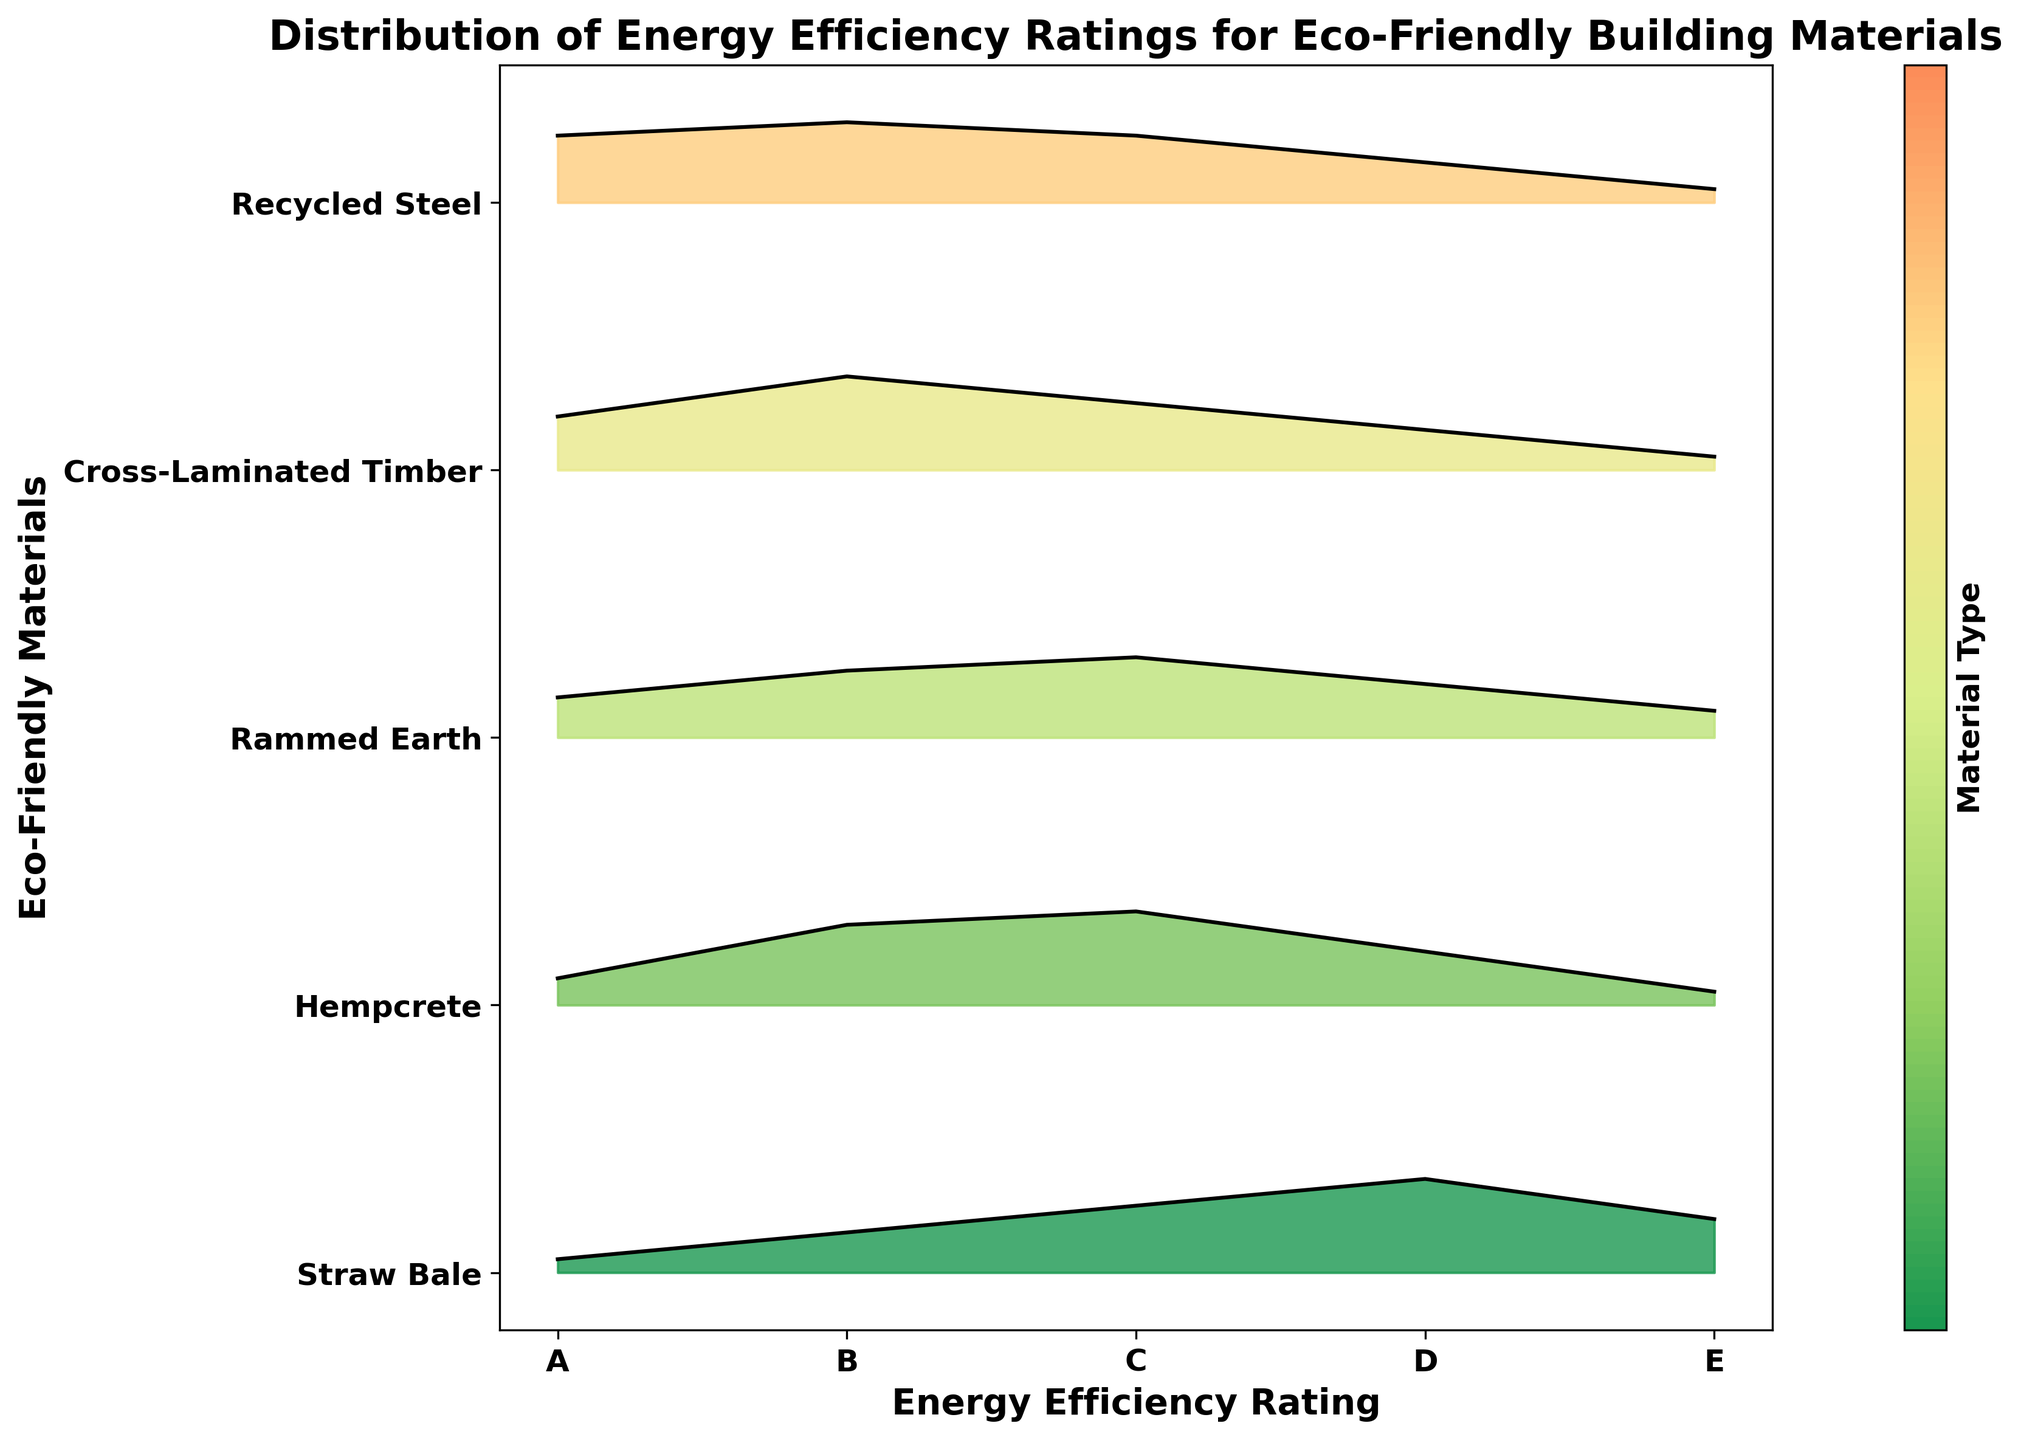What is the title of the plot? The title is typically located at the top of the plot. It summarizes what the plot represents.
Answer: Distribution of Energy Efficiency Ratings for Eco-Friendly Building Materials Which material has the highest frequency for the highest rating (A)? Examining the highest peaks at the 'A' rating on the x-axis, identify which material has the tallest peak.
Answer: Recycled Steel Which material has the lowest frequency for the lowest rating (E)? Look at the smallest peak at the 'E' rating on the x-axis and note which material aligns with it.
Answer: Cross-Laminated Timber How does the distribution of energy efficiency ratings for Straw Bale compare to Hempcrete? Compare the shapes of the ridgelines for Straw Bale and Hempcrete across the ratings from A to E. Straw Bale generally shows a higher frequency in lower ratings (D, E), while Hempcrete peaks at B and C.
Answer: Straw Bale tends towards lower ratings, Hempcrete towards middle ratings What is the most common energy efficiency rating for Cross-Laminated Timber? Observe the peaks for Cross-Laminated Timber across ratings and identify the highest one.
Answer: B Which material has the most even distribution of energy efficiency ratings? Look for ridgelines that do not show large spikes or dips across the ratings, indicating an even spread.
Answer: Rammed Earth Rank the materials from highest to lowest based on their frequency for rating 'C'. Compare the heights of the peaks at 'C' for each material and rank them accordingly.
Answer: Hempcrete > Rammed Earth > Cross-Laminated Timber = Recycled Steel > Straw Bale Are there any materials that don't have any ratings in category 'A'? Check each material's ridgeline at rating 'A' to see if any have no visible peak or area.
Answer: No, all materials have some frequency in 'A' Which material has the greatest range of frequencies across all ratings? Look at the ridgeline shapes and identify the material with the largest difference between its highest and lowest points.
Answer: Straw Bale How do the frequencies for energy efficiency ratings 'B' and 'D' compare for Recycled Steel? Compare the peaks at 'B' and 'D' for Recycled Steel by looking at their heights.
Answer: Higher at B than D 